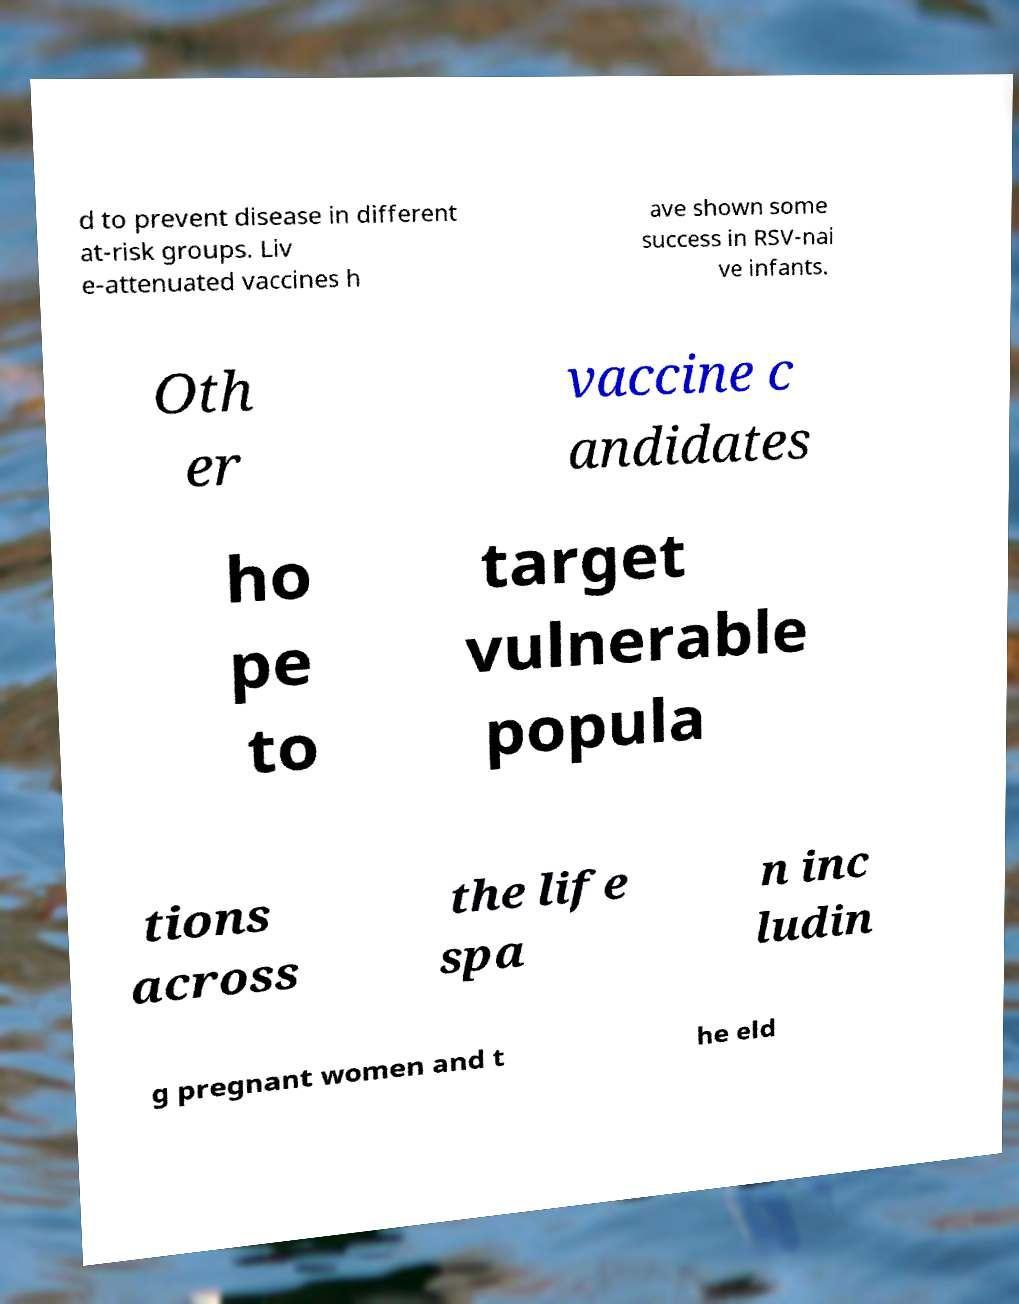There's text embedded in this image that I need extracted. Can you transcribe it verbatim? d to prevent disease in different at-risk groups. Liv e-attenuated vaccines h ave shown some success in RSV-nai ve infants. Oth er vaccine c andidates ho pe to target vulnerable popula tions across the life spa n inc ludin g pregnant women and t he eld 